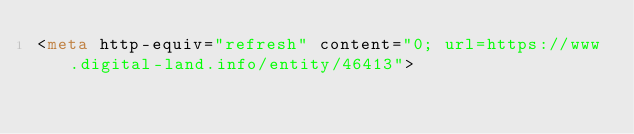Convert code to text. <code><loc_0><loc_0><loc_500><loc_500><_HTML_><meta http-equiv="refresh" content="0; url=https://www.digital-land.info/entity/46413"></code> 